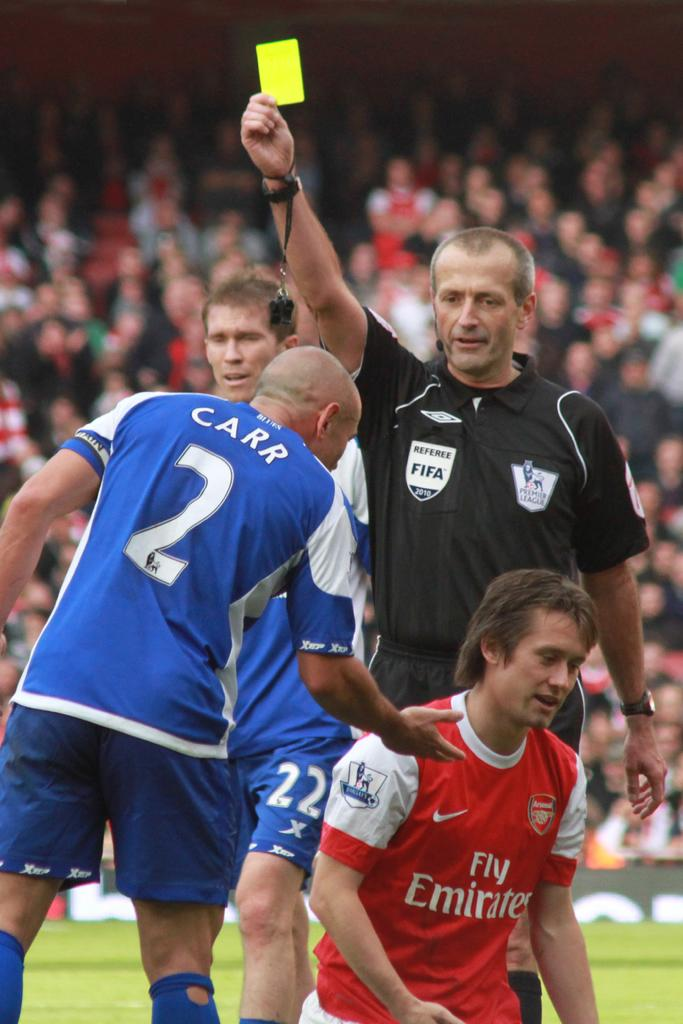<image>
Present a compact description of the photo's key features. Man wearing a number2 jersey giving a hand to a man wearing a Fly Emirates jersey. 